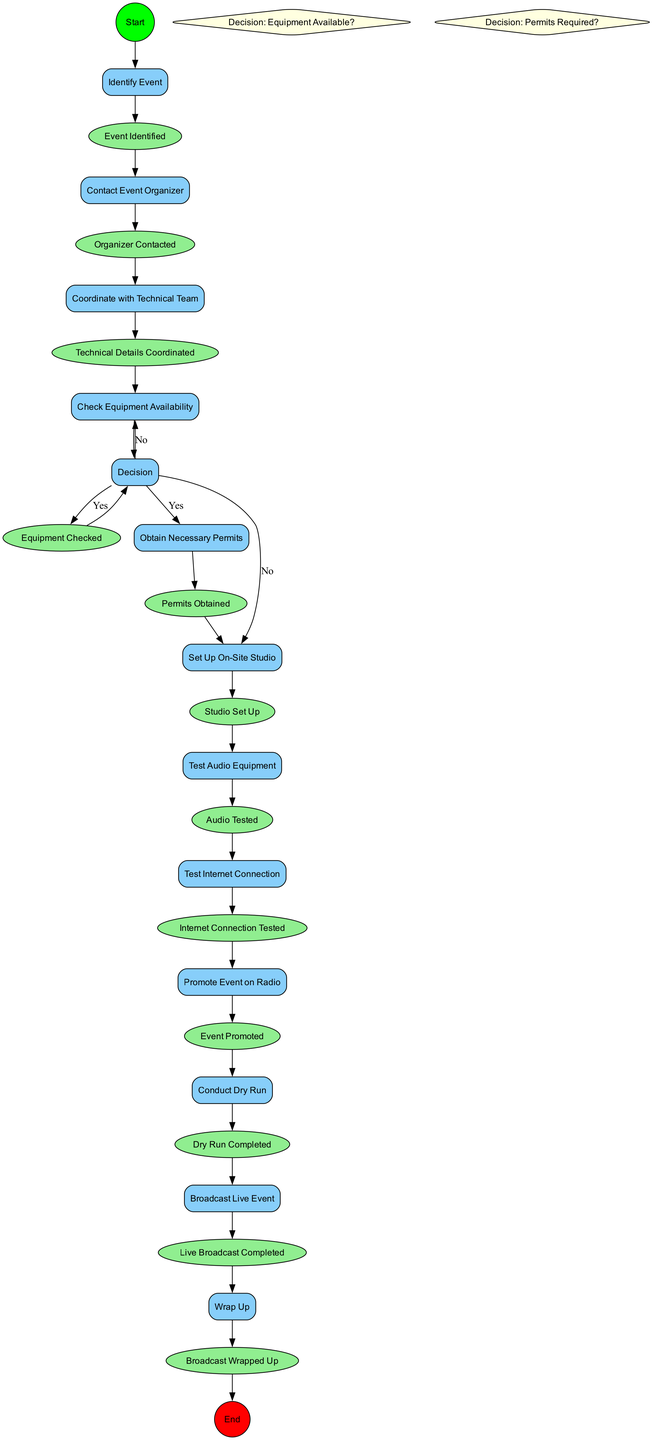What is the first activity in the diagram? The first activity is labeled "Identify Event," which is the starting point of the process outlined in the diagram. This is the very first step that initiates the workflow for setting up a remote broadcast.
Answer: Identify Event How many activities are there in total? The diagram lists a total of 11 activities that are part of the process for setting up a remote broadcast. This can be counted by identifying each activity node present in the diagram.
Answer: 11 What happens after "Check Equipment Availability"? After "Check Equipment Availability," there is a decision node labeled "Decision: Equipment Available?" that determines whether equipment is available or not, leading to different branches based on the decision made.
Answer: Decision: Equipment Available? What is the decision made if equipment is not available? If the equipment is not available, the process loops back to "Check Equipment Availability," indicating that the team needs to check equipment availability again before proceeding further.
Answer: Check Equipment Availability What is the final event in the process? The final event in the process is labeled "Broadcast Wrapped Up," marking the conclusion of the workflow after the live event has been broadcast. This signifies the end of the entire broadcasting process.
Answer: Broadcast Wrapped Up What comes right before "Test Internet Connection"? The activity that comes right before "Test Internet Connection" is "Audio Tested." This shows the sequential steps that must be completed in order before testing the internet connection.
Answer: Audio Tested How many decision points are there in the diagram? There are 2 decision points in the diagram outlined as "Decision: Equipment Available?" and "Decision: Permits Required?", which guide the flow of activities based on certain criteria.
Answer: 2 What leads to the "Live Broadcast Completed" event? The event "Live Broadcast Completed" is reached after successfully completing the activity "Broadcast Live Event," indicating that the live broadcasting has finished. This shows a direct connection between the two nodes.
Answer: Broadcast Live Event What must be completed before promoting the event on the radio? Before promoting the event on the radio, the preceding task "Test Internet Connection" must be completed along with confirming the internet connection is tested properly. This is a prerequisite for promoting the event.
Answer: Test Internet Connection 